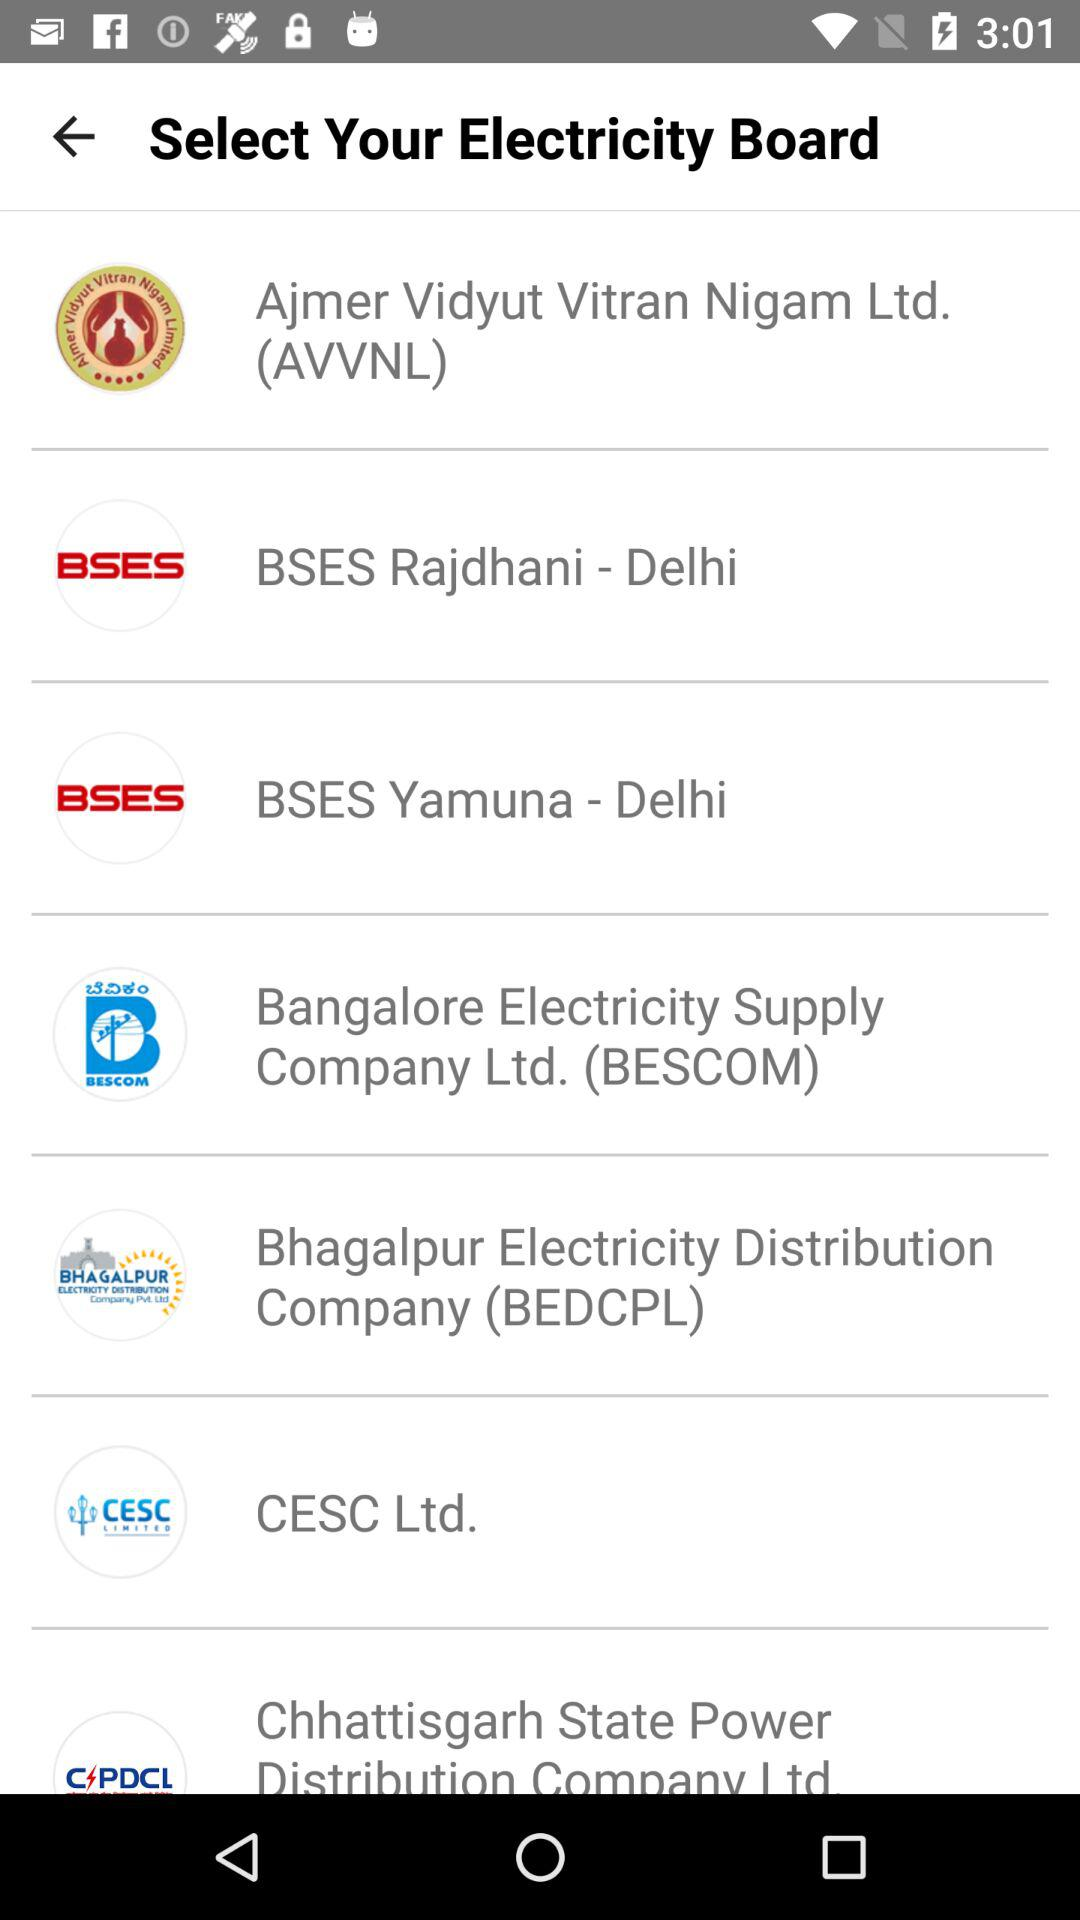How many electricity boards are from the state of Delhi?
Answer the question using a single word or phrase. 2 